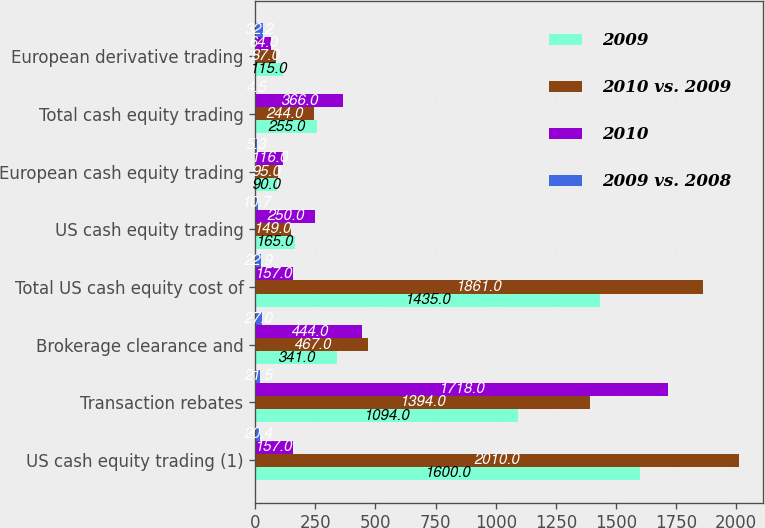Convert chart to OTSL. <chart><loc_0><loc_0><loc_500><loc_500><stacked_bar_chart><ecel><fcel>US cash equity trading (1)<fcel>Transaction rebates<fcel>Brokerage clearance and<fcel>Total US cash equity cost of<fcel>US cash equity trading<fcel>European cash equity trading<fcel>Total cash equity trading<fcel>European derivative trading<nl><fcel>2009<fcel>1600<fcel>1094<fcel>341<fcel>1435<fcel>165<fcel>90<fcel>255<fcel>115<nl><fcel>2010 vs. 2009<fcel>2010<fcel>1394<fcel>467<fcel>1861<fcel>149<fcel>95<fcel>244<fcel>87<nl><fcel>2010<fcel>157<fcel>1718<fcel>444<fcel>157<fcel>250<fcel>116<fcel>366<fcel>64<nl><fcel>2009 vs. 2008<fcel>20.4<fcel>21.5<fcel>27<fcel>22.9<fcel>10.7<fcel>5.3<fcel>4.5<fcel>32.2<nl></chart> 